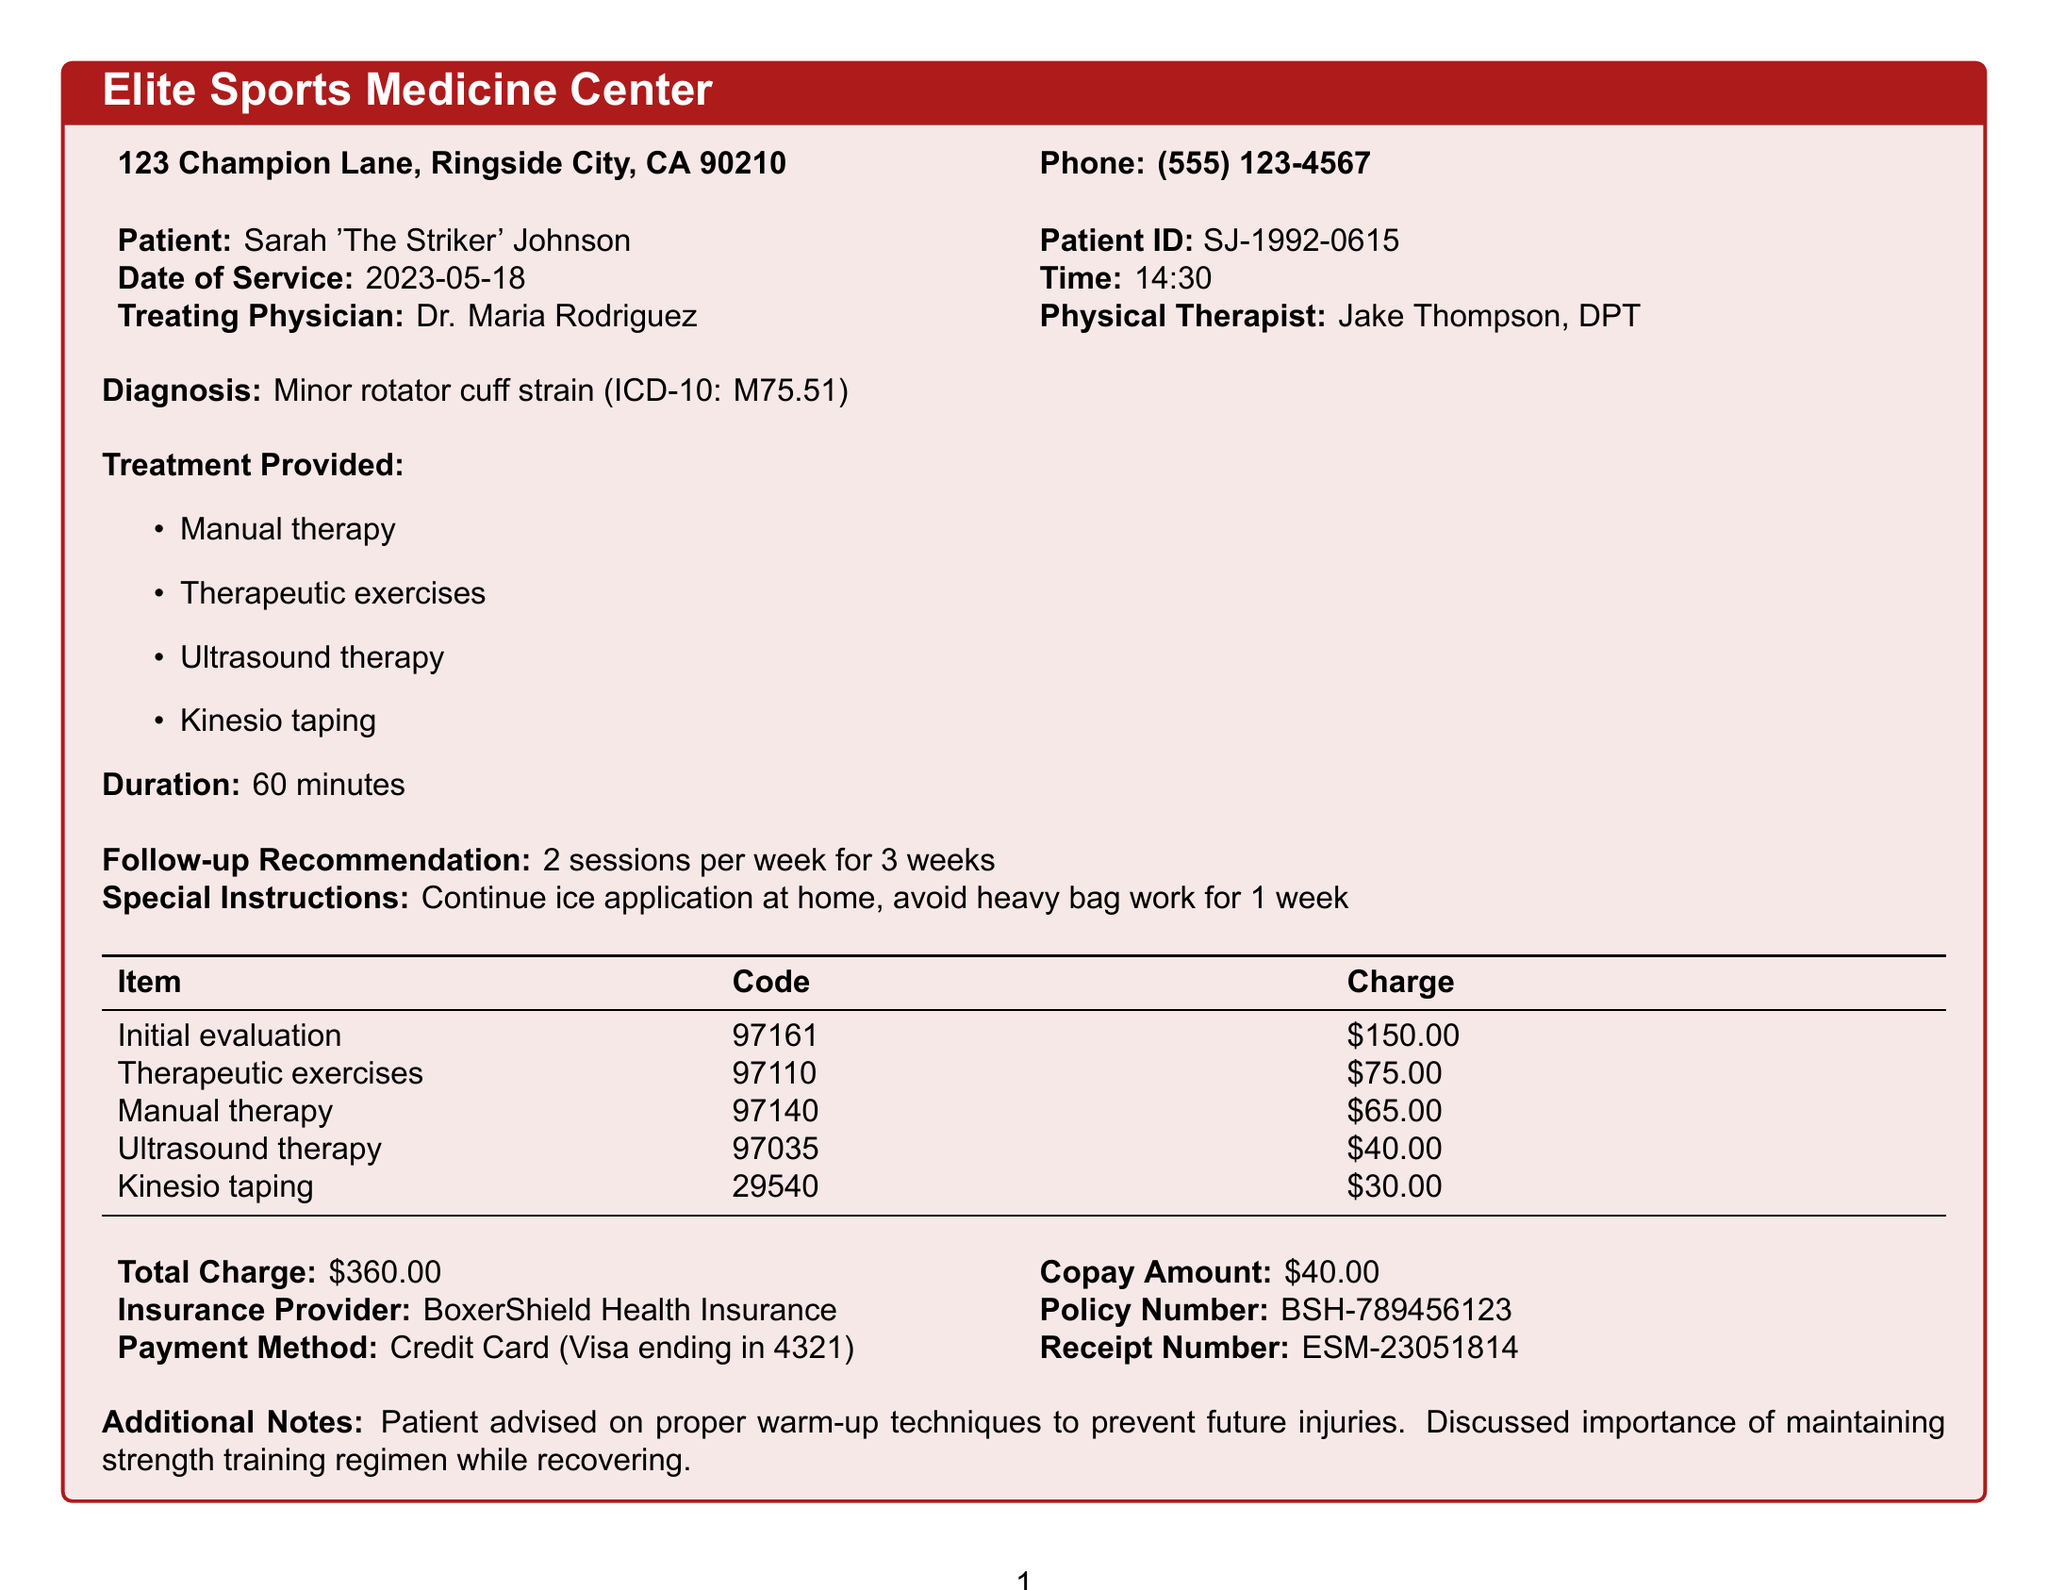What is the name of the clinic? The clinic name is explicitly mentioned in the document as "Elite Sports Medicine Center."
Answer: Elite Sports Medicine Center Who is the patient? The document provides the name of the patient, which is "Sarah 'The Striker' Johnson."
Answer: Sarah 'The Striker' Johnson What is the diagnosis? The diagnosis is clearly stated in the document as "Minor rotator cuff strain (ICD-10: M75.51)."
Answer: Minor rotator cuff strain (ICD-10: M75.51) How many sessions per week are recommended for follow-up? The follow-up recommendation specifies "2 sessions per week for 3 weeks."
Answer: 2 sessions What is the total charge for the physical therapy session? The total charge is listed in the document, which amounts to "$360.00."
Answer: $360.00 Who was the treating physician? The name of the treating physician is provided in the document as "Dr. Maria Rodriguez."
Answer: Dr. Maria Rodriguez What special instruction was given to the patient? The document states the special instruction: "Continue ice application at home, avoid heavy bag work for 1 week."
Answer: Continue ice application at home, avoid heavy bag work for 1 week What payment method was used? The payment method is listed in the document as "Credit Card (Visa ending in 4321)."
Answer: Credit Card (Visa ending in 4321) What is the receipt number? The receipt number is specified in the document, which is "ESM-23051814."
Answer: ESM-23051814 